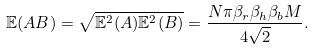<formula> <loc_0><loc_0><loc_500><loc_500>& \mathbb { E } ( A B ) = \sqrt { \mathbb { E } ^ { 2 } ( A ) \mathbb { E } ^ { 2 } ( B ) } = \frac { N \pi \beta _ { r } \beta _ { h } \beta _ { b } M } { 4 \sqrt { 2 } } . \\</formula> 